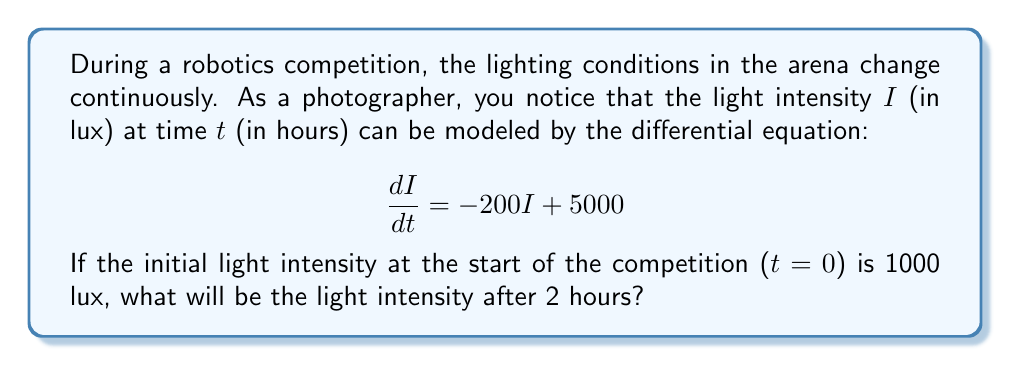Solve this math problem. To solve this problem, we need to follow these steps:

1) We have a first-order linear differential equation:
   $$\frac{dI}{dt} = -200I + 5000$$
   with the initial condition $I(0) = 1000$ lux.

2) The general solution for this type of equation is:
   $$I(t) = ce^{-200t} + 25$$
   where $c$ is a constant we need to determine.

3) To find $c$, we use the initial condition:
   $$1000 = I(0) = ce^{-200(0)} + 25$$
   $$1000 = c + 25$$
   $$c = 975$$

4) Now we have the particular solution:
   $$I(t) = 975e^{-200t} + 25$$

5) To find the light intensity after 2 hours, we evaluate $I(2)$:
   $$I(2) = 975e^{-200(2)} + 25$$
   $$I(2) = 975e^{-400} + 25$$

6) Using a calculator to evaluate $e^{-400}$, we get:
   $$I(2) \approx 975(3.87 \times 10^{-174}) + 25$$
   $$I(2) \approx 25 \text{ lux}$$

The exponential term is effectively zero due to the large negative exponent.
Answer: After 2 hours, the light intensity will be approximately 25 lux. 